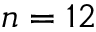Convert formula to latex. <formula><loc_0><loc_0><loc_500><loc_500>n = 1 2</formula> 